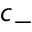<formula> <loc_0><loc_0><loc_500><loc_500>c _ { - }</formula> 